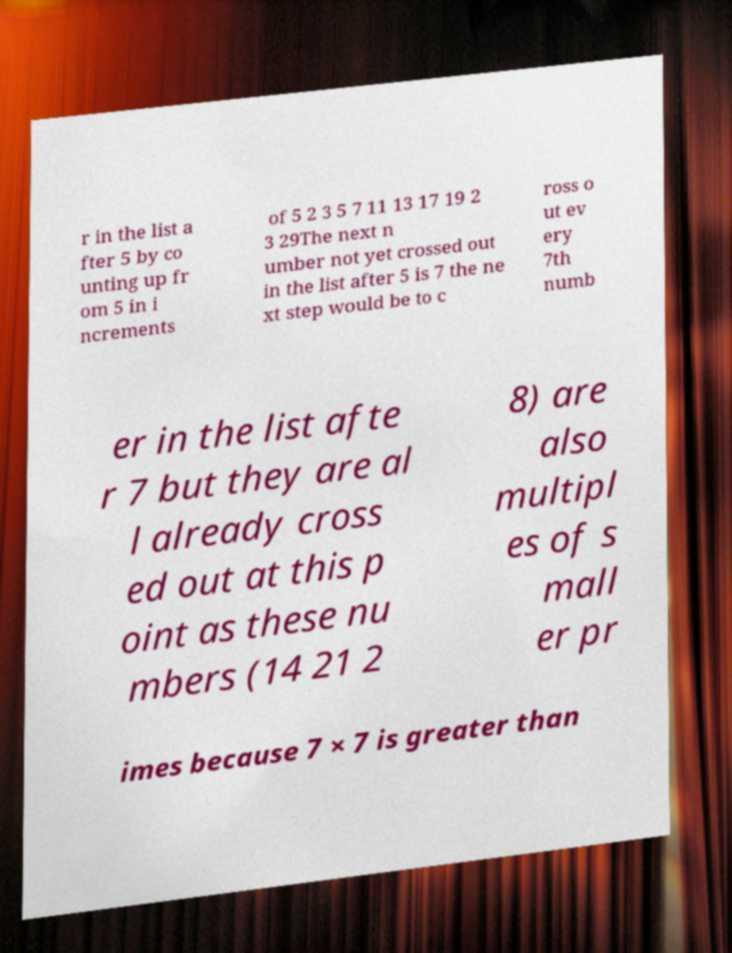Please read and relay the text visible in this image. What does it say? r in the list a fter 5 by co unting up fr om 5 in i ncrements of 5 2 3 5 7 11 13 17 19 2 3 29The next n umber not yet crossed out in the list after 5 is 7 the ne xt step would be to c ross o ut ev ery 7th numb er in the list afte r 7 but they are al l already cross ed out at this p oint as these nu mbers (14 21 2 8) are also multipl es of s mall er pr imes because 7 × 7 is greater than 